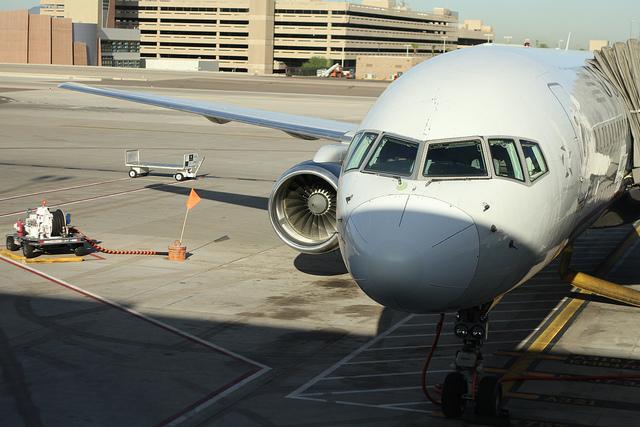How many stores is the parking garage in the back?
Write a very short answer. 6. What color is the flag?
Quick response, please. Orange. Is there anyone in the cockpit?
Short answer required. No. What is happening to the plane?
Write a very short answer. Boarding. 